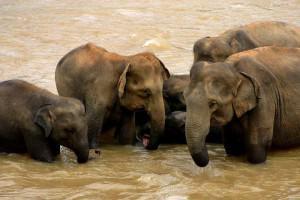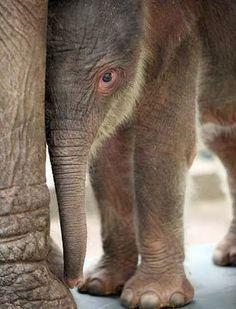The first image is the image on the left, the second image is the image on the right. Analyze the images presented: Is the assertion "Right image shows a forward facing baby elephant to the right of an adult elephant's legs." valid? Answer yes or no. Yes. 